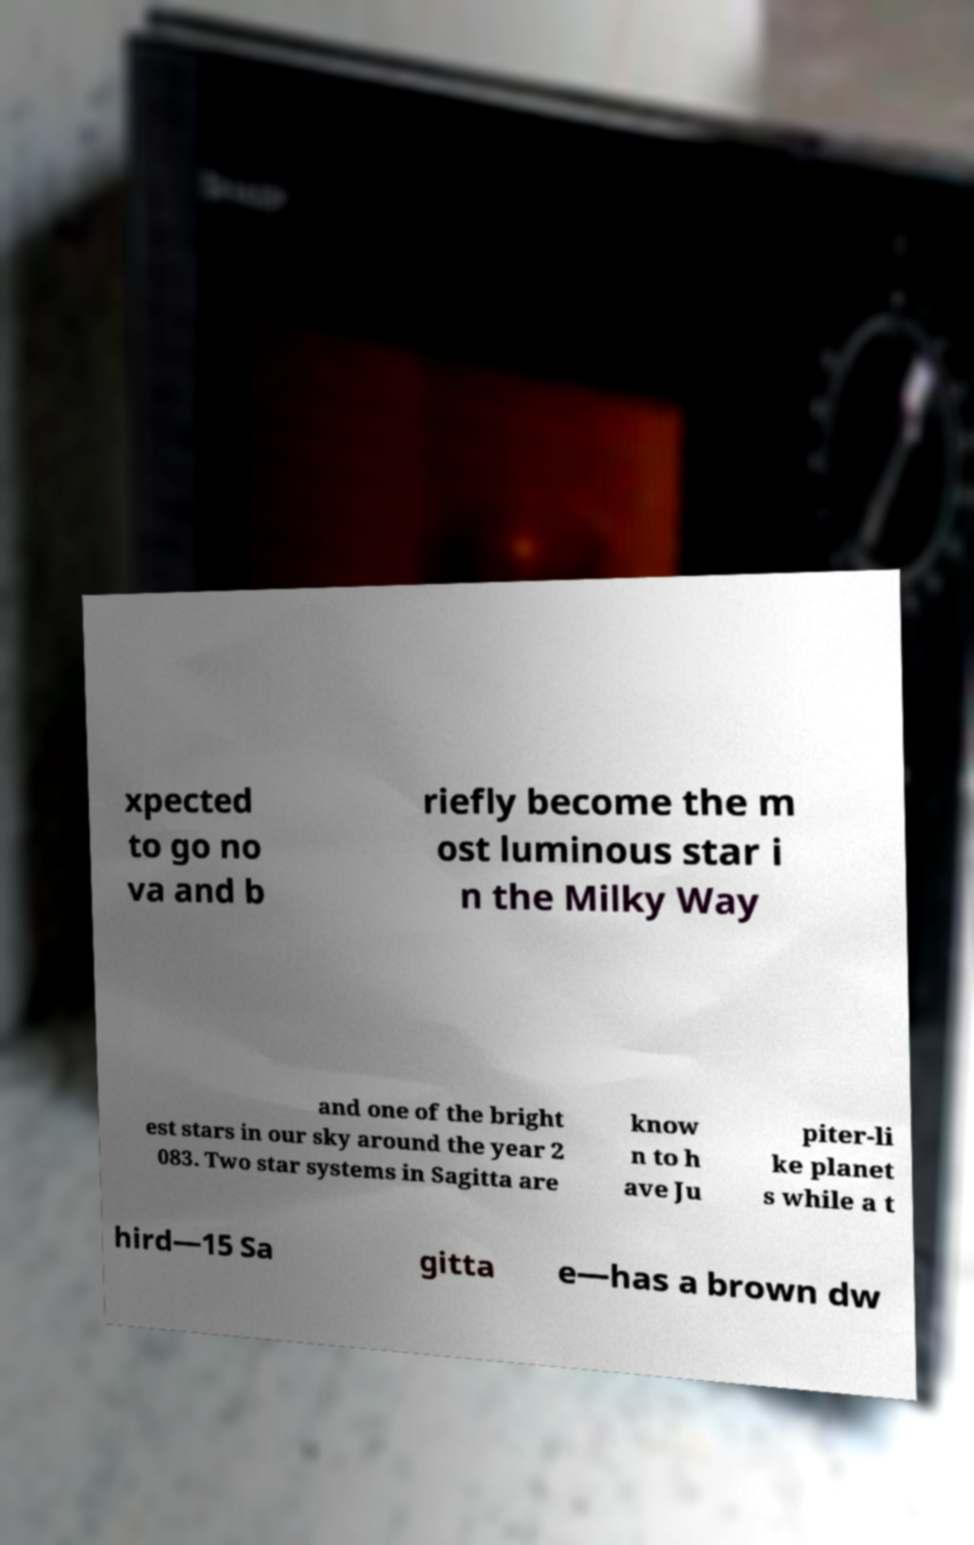Can you accurately transcribe the text from the provided image for me? xpected to go no va and b riefly become the m ost luminous star i n the Milky Way and one of the bright est stars in our sky around the year 2 083. Two star systems in Sagitta are know n to h ave Ju piter-li ke planet s while a t hird—15 Sa gitta e—has a brown dw 